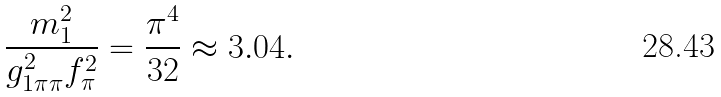Convert formula to latex. <formula><loc_0><loc_0><loc_500><loc_500>\frac { m _ { 1 } ^ { 2 } } { g _ { 1 \pi \pi } ^ { 2 } f _ { \pi } ^ { 2 } } = \frac { \pi ^ { 4 } } { 3 2 } \approx 3 . 0 4 .</formula> 